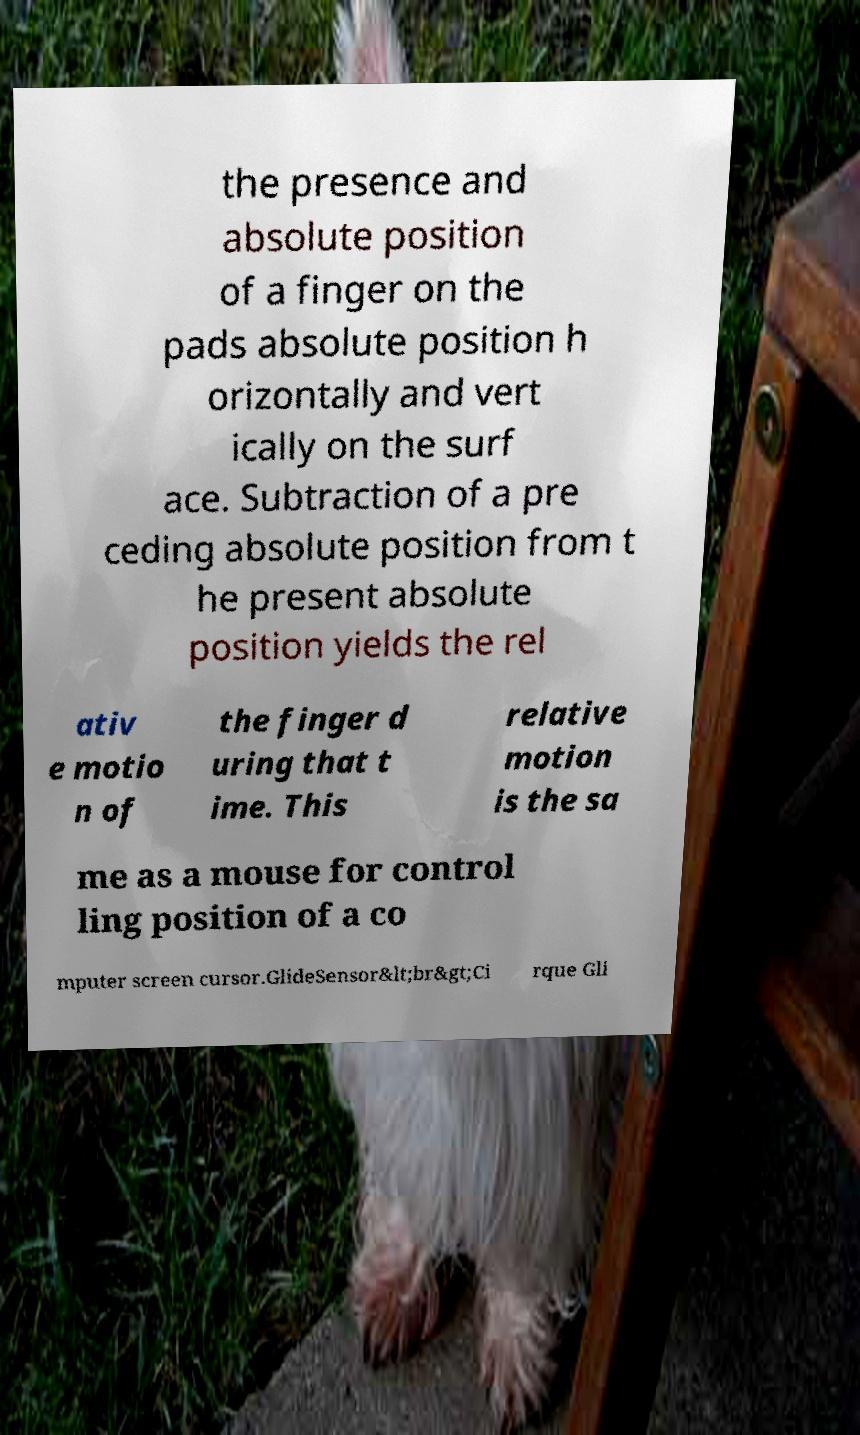There's text embedded in this image that I need extracted. Can you transcribe it verbatim? the presence and absolute position of a finger on the pads absolute position h orizontally and vert ically on the surf ace. Subtraction of a pre ceding absolute position from t he present absolute position yields the rel ativ e motio n of the finger d uring that t ime. This relative motion is the sa me as a mouse for control ling position of a co mputer screen cursor.GlideSensor&lt;br&gt;Ci rque Gli 